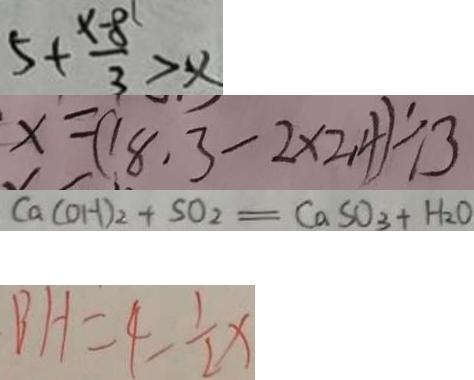<formula> <loc_0><loc_0><loc_500><loc_500>5 + \frac { x - 8 } { 3 } > x 
 x = ( 1 8 . 3 - 2 \times 2 . 4 ) \div 3 
 C a ( O H ) _ { 2 } + S O _ { 2 } = C a S O _ { 3 } + H _ { 2 } O 
 B H = 4 - \frac { 1 } { 2 } x</formula> 